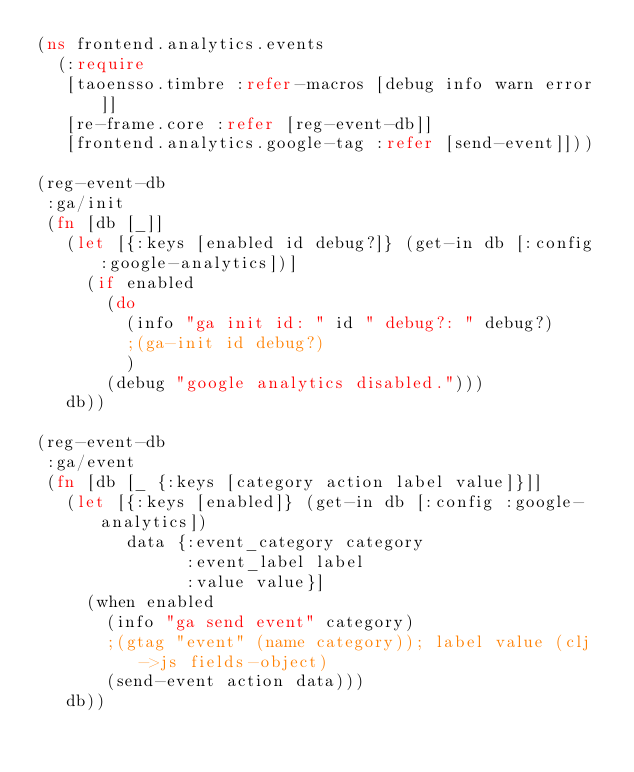Convert code to text. <code><loc_0><loc_0><loc_500><loc_500><_Clojure_>(ns frontend.analytics.events
  (:require
   [taoensso.timbre :refer-macros [debug info warn error]]
   [re-frame.core :refer [reg-event-db]]
   [frontend.analytics.google-tag :refer [send-event]]))

(reg-event-db
 :ga/init
 (fn [db [_]]
   (let [{:keys [enabled id debug?]} (get-in db [:config :google-analytics])]
     (if enabled
       (do
         (info "ga init id: " id " debug?: " debug?)
         ;(ga-init id debug?)
         )
       (debug "google analytics disabled.")))
   db))

(reg-event-db
 :ga/event
 (fn [db [_ {:keys [category action label value]}]]
   (let [{:keys [enabled]} (get-in db [:config :google-analytics])
         data {:event_category category
               :event_label label
               :value value}]
     (when enabled
       (info "ga send event" category)
       ;(gtag "event" (name category)); label value (clj->js fields-object)
       (send-event action data)))
   db))
</code> 